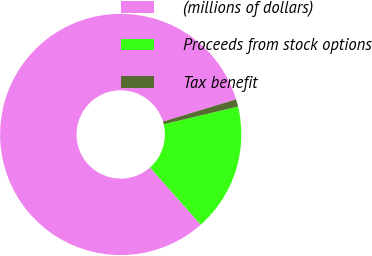Convert chart to OTSL. <chart><loc_0><loc_0><loc_500><loc_500><pie_chart><fcel>(millions of dollars)<fcel>Proceeds from stock options<fcel>Tax benefit<nl><fcel>81.84%<fcel>17.16%<fcel>0.99%<nl></chart> 